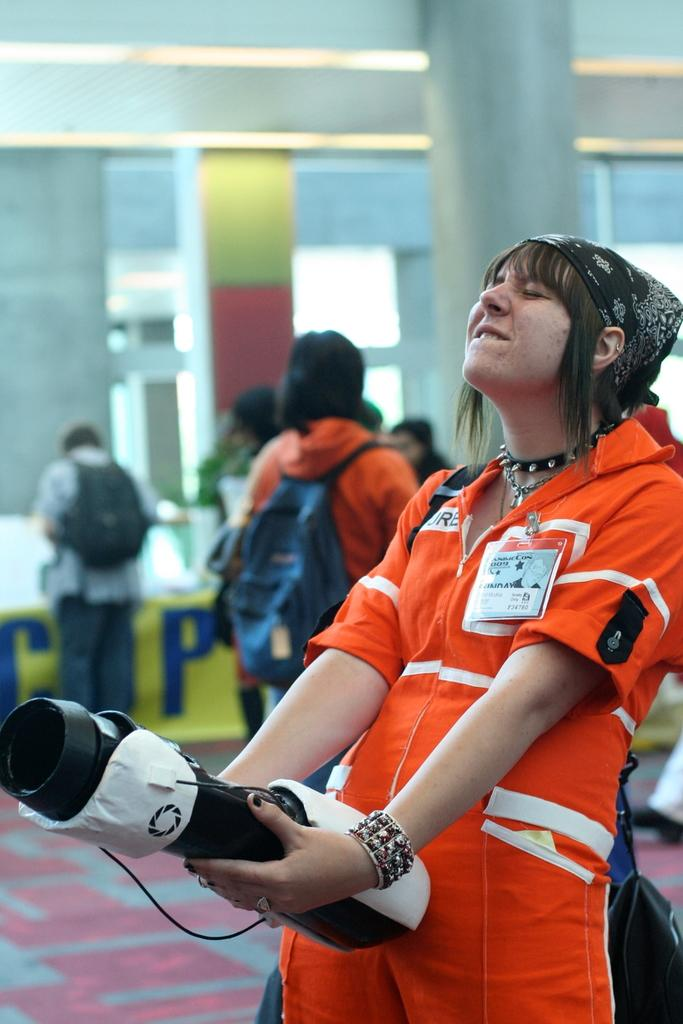What is the woman in the image wearing? The woman is wearing an orange dress. What is the woman's facial expression in the image? The woman is smiling. What is the woman's posture in the image? The woman is standing. What is the woman holding in the image? The woman is holding an object. What can be seen in the background of the image? There are persons on the floor, pillars, and a wall in the background of the image. What is the price of the food being served in the image? There is no food being served in the image, so it is not possible to determine the price. 